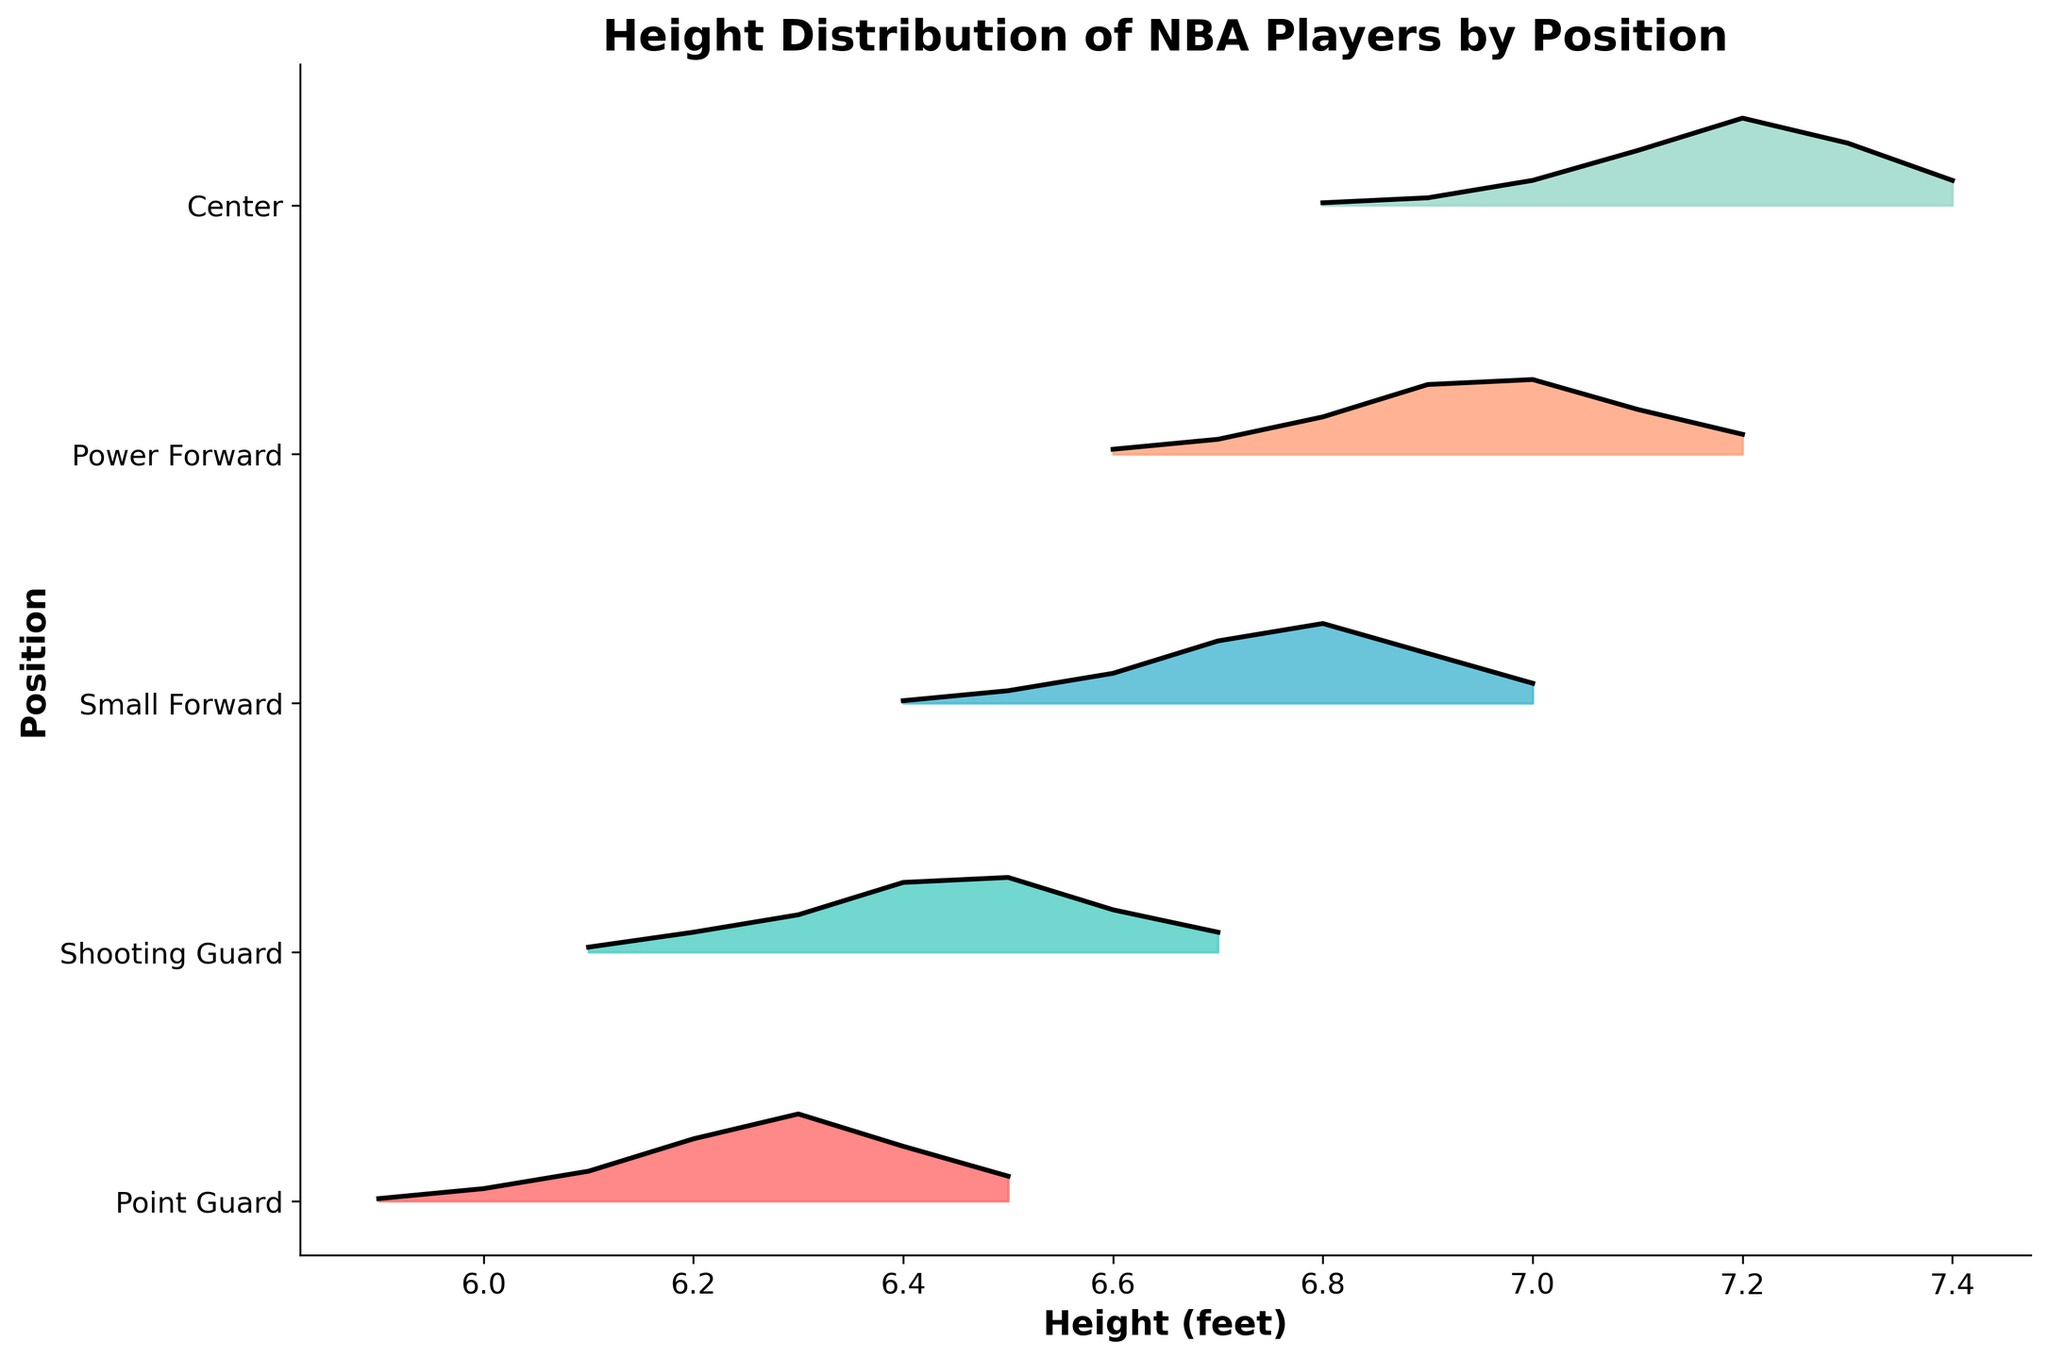What is the highest density height for Point Guards? Identify the peak of the density curve for Point Guards by locating the height with the highest density value. The highest peak on the curve is at 6.3 feet.
Answer: 6.3 feet Which player position has the tallest height on the plot? Look at the x-axis to check the upper range of heights for all positions. Centers have the tallest height, reaching up to 7.4 feet.
Answer: Center What height do Power Forwards most commonly have? Find the height at which the density curve for Power Forwards peaks. The tallest peak for Power Forwards occurs at 7.0 feet.
Answer: 7.0 feet Are Shooting Guards taller on average than Point Guards? Compare the range and peaks of the density curves for both positions. Shooting Guards have a higher average height, with peaks around 6.4-6.5 feet, compared to Point Guards peaking at 6.3 feet.
Answer: Yes How many height categories are shown for Small Forwards? Count the distinct heights shown on the x-axis under the Small Forwards curve. There are 7 distinct heights (6.4 to 7.0 feet).
Answer: 7 Which player position has the widest height distribution? Compare the spread of heights for each position by examining the range of the x-axis for each curve. Centers have the widest distribution, ranging from 6.8 to 7.4 feet.
Answer: Center Is there any overlap in the height distributions of Centers and Power Forwards? Check the x-axis ranges for both Centers and Power Forwards and see if there is a common height range. Both positions share the heights 6.8 to 7.2 feet.
Answer: Yes Which position shows the sharpest drop-off in density after the peak height? Look at the steepness of the decline after the peak of each density curve. Point Guards have the sharpest drop-off after 6.3 feet.
Answer: Point Guards What is the common height range for all five positions? Find the overlapping region on the x-axis where all positions have height data. The common range is from 6.6 to 6.9 feet.
Answer: 6.6 to 6.9 feet 